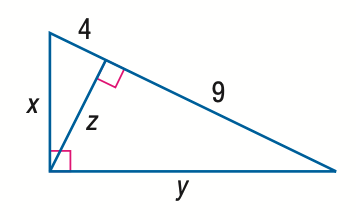Question: Find z.
Choices:
A. 4
B. 6
C. 9
D. 36
Answer with the letter. Answer: B Question: Find y.
Choices:
A. 6
B. 3 \sqrt { 5 }
C. 9
D. 3 \sqrt { 13 }
Answer with the letter. Answer: D Question: Find x.
Choices:
A. 4
B. 2 \sqrt { 5 }
C. 6
D. 2 \sqrt { 13 }
Answer with the letter. Answer: D 